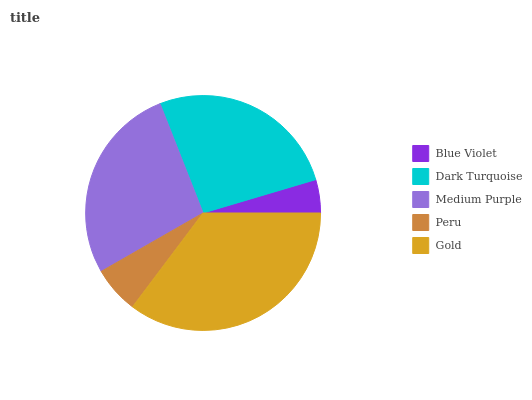Is Blue Violet the minimum?
Answer yes or no. Yes. Is Gold the maximum?
Answer yes or no. Yes. Is Dark Turquoise the minimum?
Answer yes or no. No. Is Dark Turquoise the maximum?
Answer yes or no. No. Is Dark Turquoise greater than Blue Violet?
Answer yes or no. Yes. Is Blue Violet less than Dark Turquoise?
Answer yes or no. Yes. Is Blue Violet greater than Dark Turquoise?
Answer yes or no. No. Is Dark Turquoise less than Blue Violet?
Answer yes or no. No. Is Dark Turquoise the high median?
Answer yes or no. Yes. Is Dark Turquoise the low median?
Answer yes or no. Yes. Is Medium Purple the high median?
Answer yes or no. No. Is Blue Violet the low median?
Answer yes or no. No. 